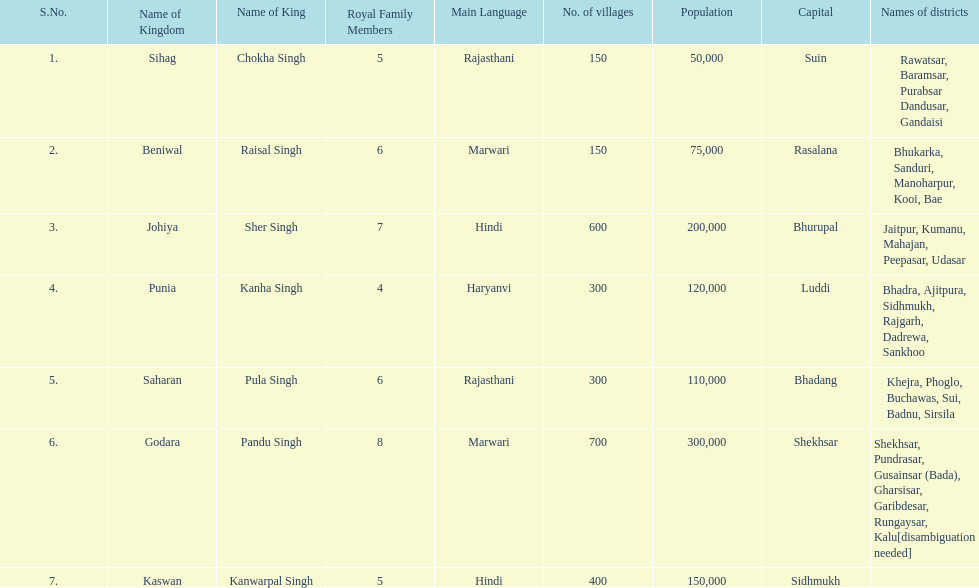Which realm had the second-highest number of villages, following godara? Johiya. 